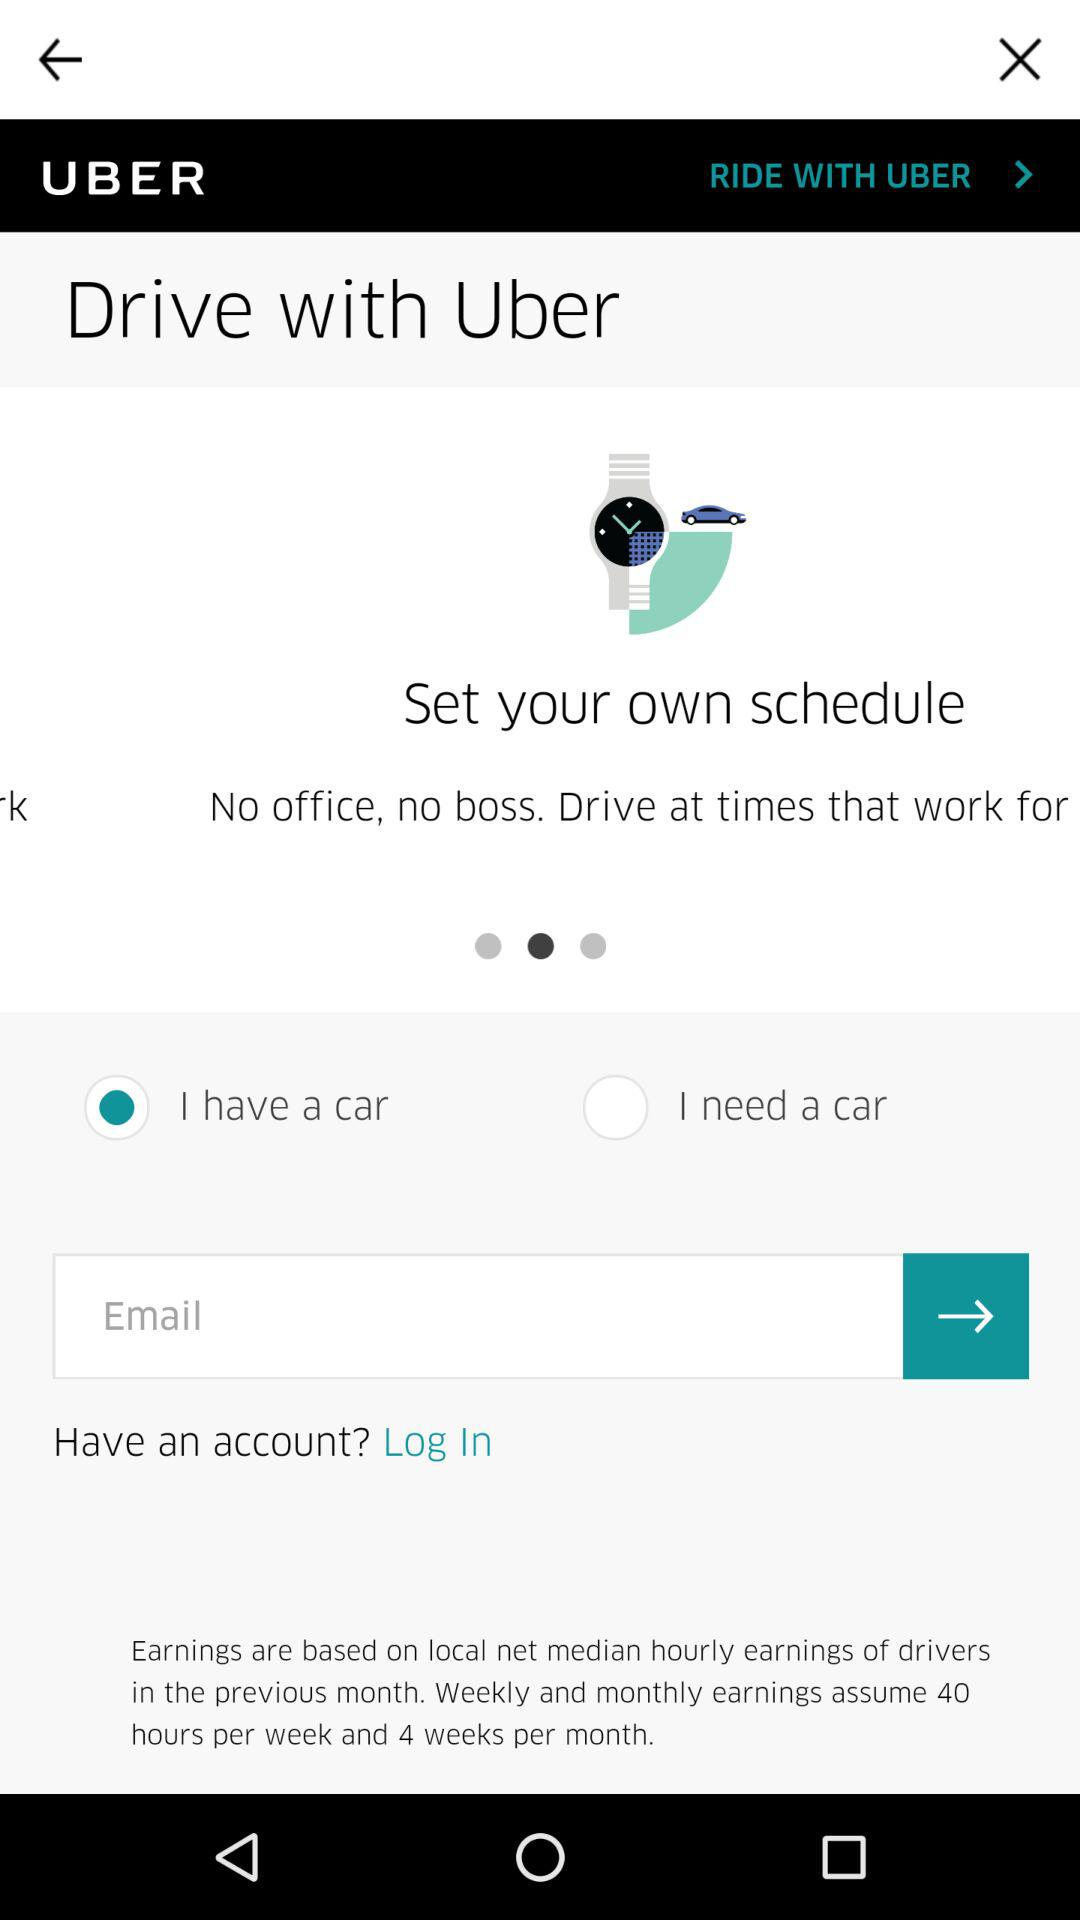How many hours per week does the earnings estimate assume?
Answer the question using a single word or phrase. 40 